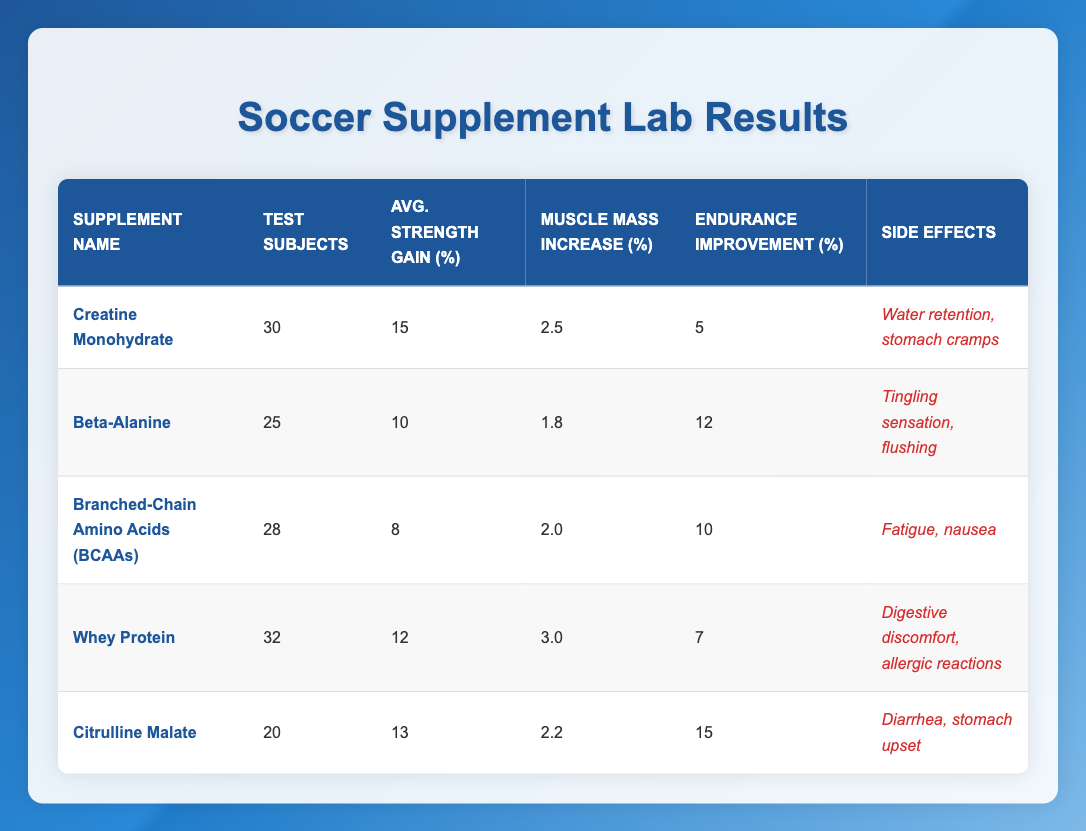What is the average strength gain for Creatine Monohydrate? The average strength gain for Creatine Monohydrate is listed directly in the table as 15.
Answer: 15 How many test subjects were involved in the study of Whey Protein? The number of test subjects for Whey Protein is shown in the table as 32.
Answer: 32 Which supplement has the highest endurance improvement percentage? By examining the endurance improvement percentages for all supplements, Citrulline Malate has the highest value at 15.
Answer: Citrulline Malate What are the side effects associated with Beta-Alanine? The side effects of Beta-Alanine are specifically listed in the table as tingling sensation and flushing.
Answer: Tingling sensation, flushing What is the total number of test subjects across all supplements? To find the total number of test subjects, sum the individual numbers given: 30 + 25 + 28 + 32 + 20 = 135.
Answer: 135 Is the muscle mass increase for Branched-Chain Amino Acids greater than 2%? The muscle mass increase for BCAAs is 2.0%, which is not greater than 2%. Therefore, the answer is no.
Answer: No What is the average endurance improvement for all supplements? To find the average endurance improvement, sum the percentages (5 + 12 + 10 + 7 + 15) = 49, and divide by the number of supplements (5): 49 / 5 = 9.8.
Answer: 9.8 Which supplement has the lowest average strength gain, and what is that value? By checking the average strength gains in the table, Branched-Chain Amino Acids have the lowest strength gain of 8.
Answer: Branched-Chain Amino Acids, 8 If a player is sensitive to digestive issues, which supplement should they avoid based on the side effects? Whey Protein is noted to cause digestive discomfort and allergic reactions, making it unsuitable for players sensitive to digestive issues.
Answer: Whey Protein 